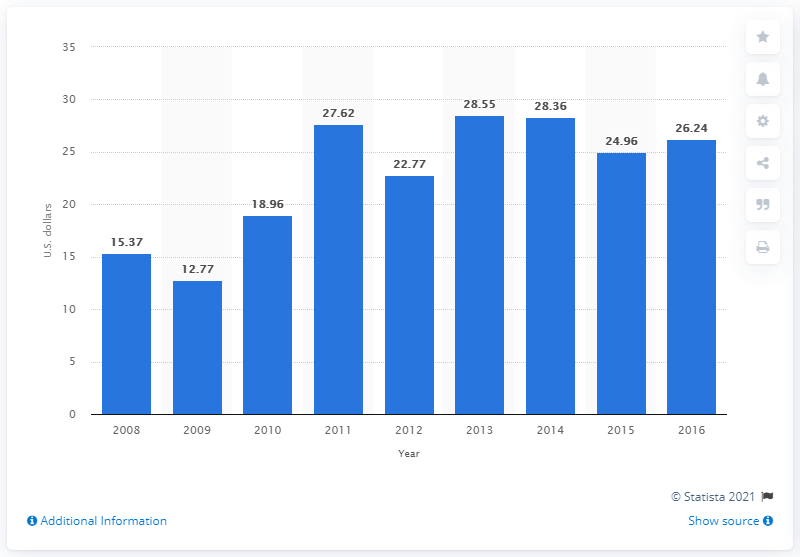Highlight a few significant elements in this photo. In 2014, the average consumer spent $28.36 on Valentine's Day gifts for their pets. 